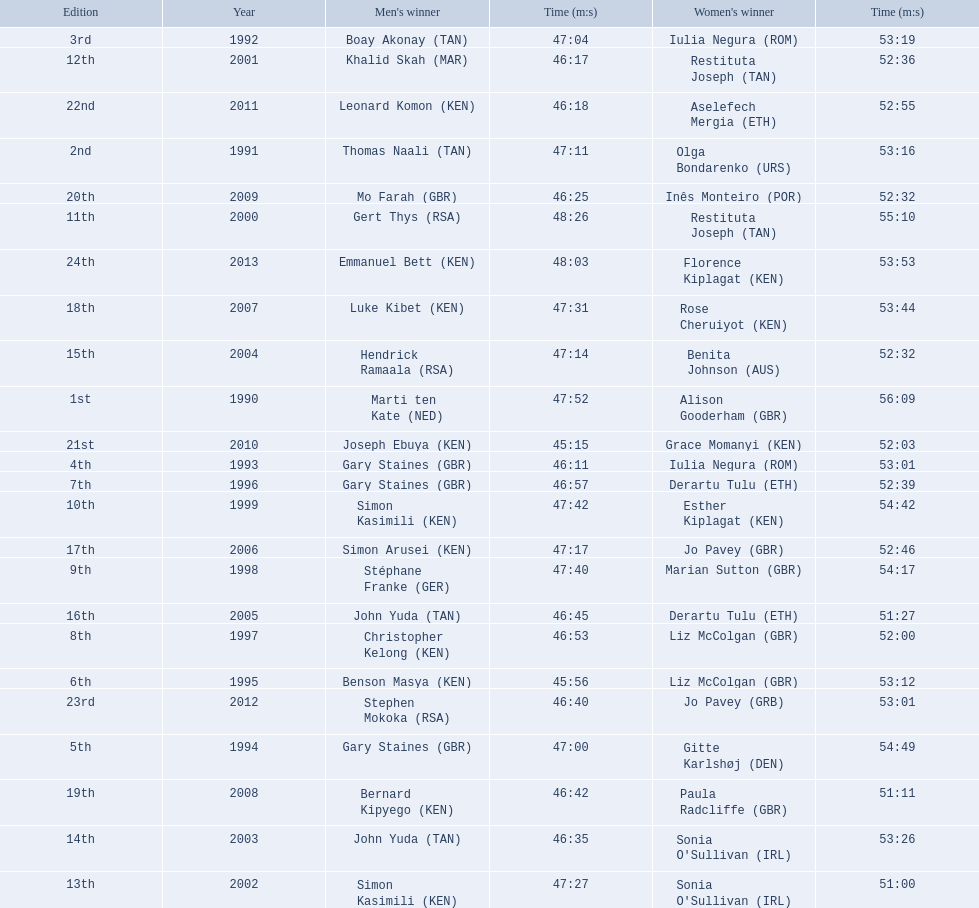What years were the races held? 1990, 1991, 1992, 1993, 1994, 1995, 1996, 1997, 1998, 1999, 2000, 2001, 2002, 2003, 2004, 2005, 2006, 2007, 2008, 2009, 2010, 2011, 2012, 2013. Who was the woman's winner of the 2003 race? Sonia O'Sullivan (IRL). What was her time? 53:26. 